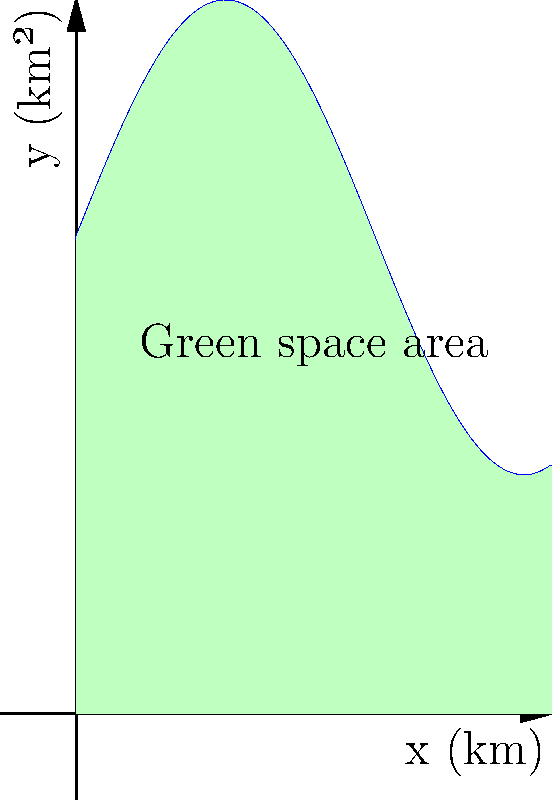As an immigrant painter in Sydney, you've noticed the changing urban landscape and its impact on green spaces. The function $f(x) = 5\sin(\frac{x}{2}) + 10$ represents the area of green space (in square kilometers) along a 10 km stretch of Sydney's coastline, where $x$ is the distance from the city center in kilometers. Calculate the total area of green space along this stretch using integration. To find the total area of green space, we need to integrate the function $f(x) = 5\sin(\frac{x}{2}) + 10$ from 0 to 10 km.

Step 1: Set up the definite integral:
$$\int_0^{10} (5\sin(\frac{x}{2}) + 10) dx$$

Step 2: Integrate the function:
$$\left[-10\cos(\frac{x}{2}) + 10x\right]_0^{10}$$

Step 3: Evaluate the integral at the bounds:
$$\left[-10\cos(5) + 100\right] - \left[-10\cos(0) + 0\right]$$

Step 4: Simplify:
$$-10\cos(5) + 100 + 10$$
$$= -10\cos(5) + 110$$

Step 5: Calculate the final result:
The value of $\cos(5)$ is approximately 0.28366, so:
$$-10(0.28366) + 110 \approx 107.1634$$

Therefore, the total area of green space along the 10 km stretch is approximately 107.1634 square kilometers.
Answer: 107.1634 km² 